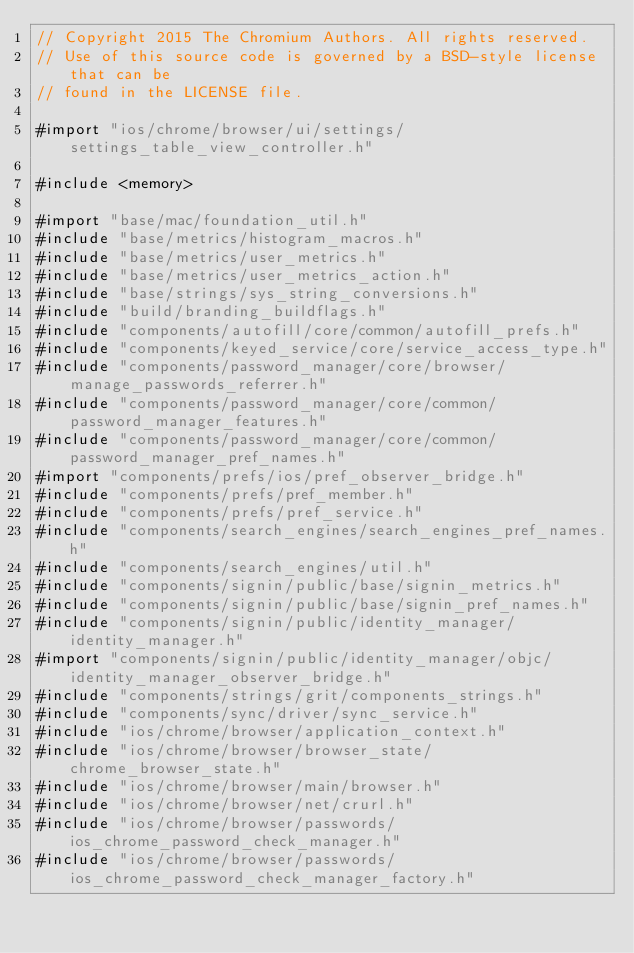<code> <loc_0><loc_0><loc_500><loc_500><_ObjectiveC_>// Copyright 2015 The Chromium Authors. All rights reserved.
// Use of this source code is governed by a BSD-style license that can be
// found in the LICENSE file.

#import "ios/chrome/browser/ui/settings/settings_table_view_controller.h"

#include <memory>

#import "base/mac/foundation_util.h"
#include "base/metrics/histogram_macros.h"
#include "base/metrics/user_metrics.h"
#include "base/metrics/user_metrics_action.h"
#include "base/strings/sys_string_conversions.h"
#include "build/branding_buildflags.h"
#include "components/autofill/core/common/autofill_prefs.h"
#include "components/keyed_service/core/service_access_type.h"
#include "components/password_manager/core/browser/manage_passwords_referrer.h"
#include "components/password_manager/core/common/password_manager_features.h"
#include "components/password_manager/core/common/password_manager_pref_names.h"
#import "components/prefs/ios/pref_observer_bridge.h"
#include "components/prefs/pref_member.h"
#include "components/prefs/pref_service.h"
#include "components/search_engines/search_engines_pref_names.h"
#include "components/search_engines/util.h"
#include "components/signin/public/base/signin_metrics.h"
#include "components/signin/public/base/signin_pref_names.h"
#include "components/signin/public/identity_manager/identity_manager.h"
#import "components/signin/public/identity_manager/objc/identity_manager_observer_bridge.h"
#include "components/strings/grit/components_strings.h"
#include "components/sync/driver/sync_service.h"
#include "ios/chrome/browser/application_context.h"
#include "ios/chrome/browser/browser_state/chrome_browser_state.h"
#include "ios/chrome/browser/main/browser.h"
#include "ios/chrome/browser/net/crurl.h"
#include "ios/chrome/browser/passwords/ios_chrome_password_check_manager.h"
#include "ios/chrome/browser/passwords/ios_chrome_password_check_manager_factory.h"</code> 